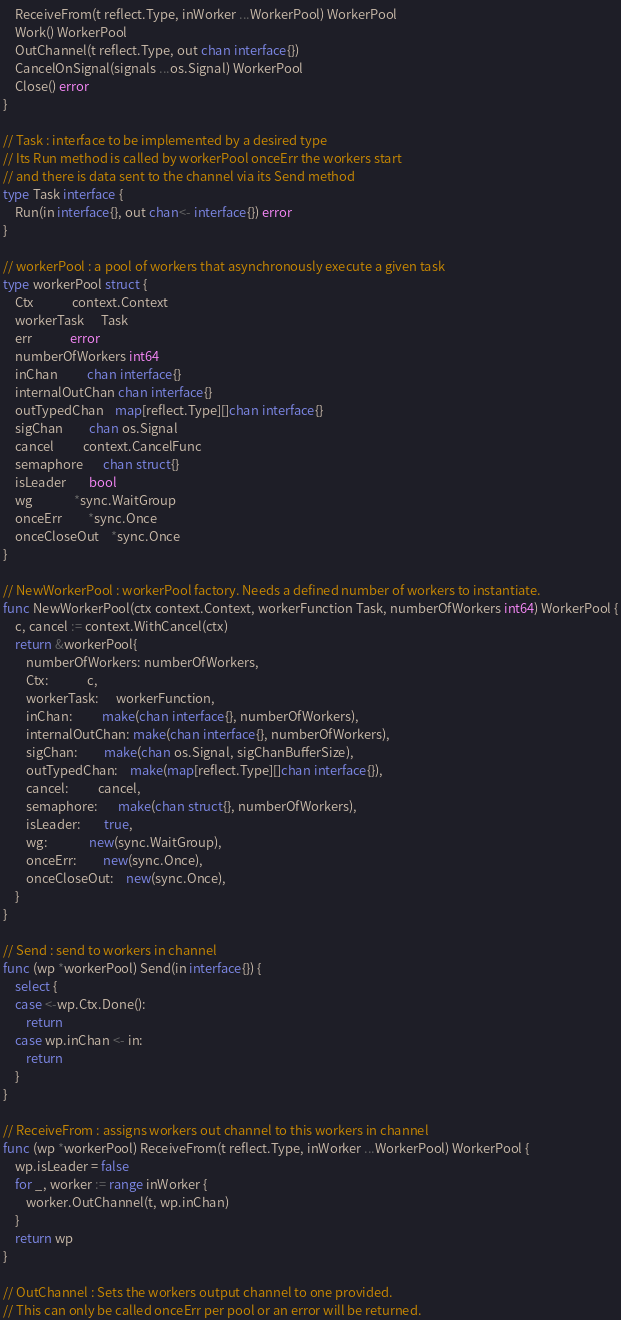Convert code to text. <code><loc_0><loc_0><loc_500><loc_500><_Go_>	ReceiveFrom(t reflect.Type, inWorker ...WorkerPool) WorkerPool
	Work() WorkerPool
	OutChannel(t reflect.Type, out chan interface{})
	CancelOnSignal(signals ...os.Signal) WorkerPool
	Close() error
}

// Task : interface to be implemented by a desired type
// Its Run method is called by workerPool onceErr the workers start
// and there is data sent to the channel via its Send method
type Task interface {
	Run(in interface{}, out chan<- interface{}) error
}

// workerPool : a pool of workers that asynchronously execute a given task
type workerPool struct {
	Ctx             context.Context
	workerTask      Task
	err             error
	numberOfWorkers int64
	inChan          chan interface{}
	internalOutChan chan interface{}
	outTypedChan    map[reflect.Type][]chan interface{}
	sigChan         chan os.Signal
	cancel          context.CancelFunc
	semaphore       chan struct{}
	isLeader        bool
	wg              *sync.WaitGroup
	onceErr         *sync.Once
	onceCloseOut    *sync.Once
}

// NewWorkerPool : workerPool factory. Needs a defined number of workers to instantiate.
func NewWorkerPool(ctx context.Context, workerFunction Task, numberOfWorkers int64) WorkerPool {
	c, cancel := context.WithCancel(ctx)
	return &workerPool{
		numberOfWorkers: numberOfWorkers,
		Ctx:             c,
		workerTask:      workerFunction,
		inChan:          make(chan interface{}, numberOfWorkers),
		internalOutChan: make(chan interface{}, numberOfWorkers),
		sigChan:         make(chan os.Signal, sigChanBufferSize),
		outTypedChan:    make(map[reflect.Type][]chan interface{}),
		cancel:          cancel,
		semaphore:       make(chan struct{}, numberOfWorkers),
		isLeader:        true,
		wg:              new(sync.WaitGroup),
		onceErr:         new(sync.Once),
		onceCloseOut:    new(sync.Once),
	}
}

// Send : send to workers in channel
func (wp *workerPool) Send(in interface{}) {
	select {
	case <-wp.Ctx.Done():
		return
	case wp.inChan <- in:
		return
	}
}

// ReceiveFrom : assigns workers out channel to this workers in channel
func (wp *workerPool) ReceiveFrom(t reflect.Type, inWorker ...WorkerPool) WorkerPool {
	wp.isLeader = false
	for _, worker := range inWorker {
		worker.OutChannel(t, wp.inChan)
	}
	return wp
}

// OutChannel : Sets the workers output channel to one provided.
// This can only be called onceErr per pool or an error will be returned.</code> 